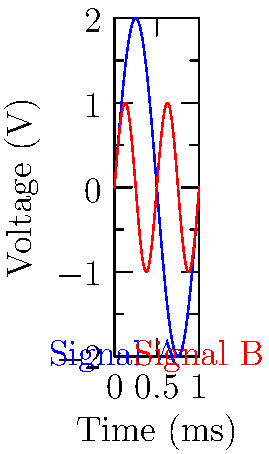As a medical expert analyzing oscilloscope waveforms for a cardiac monitoring system, you observe two signals as shown in the graph. Signal A (blue) represents the primary cardiac rhythm, while Signal B (red) shows a potential arrhythmia. What is the frequency ratio of Signal B to Signal A, and what might this indicate about the patient's heart condition? To determine the frequency ratio of Signal B to Signal A, we need to analyze the number of cycles each signal completes in the given time frame. Let's break this down step-by-step:

1. Observe Signal A (blue):
   - It completes 2 full cycles in the given time frame.
   - The frequency of Signal A is thus 2 cycles per unit time.

2. Observe Signal B (red):
   - It completes 4 full cycles in the same time frame.
   - The frequency of Signal B is thus 4 cycles per unit time.

3. Calculate the frequency ratio:
   $$ \text{Frequency Ratio} = \frac{\text{Frequency of Signal B}}{\text{Frequency of Signal A}} = \frac{4}{2} = 2 $$

4. Interpretation for cardiac monitoring:
   - Signal A likely represents the normal sinus rhythm (around 60-100 beats per minute).
   - Signal B shows a frequency exactly twice that of Signal A.
   - This could indicate a 2:1 atrial flutter, where the atria are beating twice as fast as the ventricles.

5. Clinical significance:
   - A 2:1 atrial flutter is a type of supraventricular tachycardia.
   - It suggests that every other atrial impulse is blocked at the AV node, preventing ventricular rates from becoming excessive.
   - This condition requires further investigation and potentially treatment to prevent complications.
Answer: 2:1 ratio, indicating possible atrial flutter 